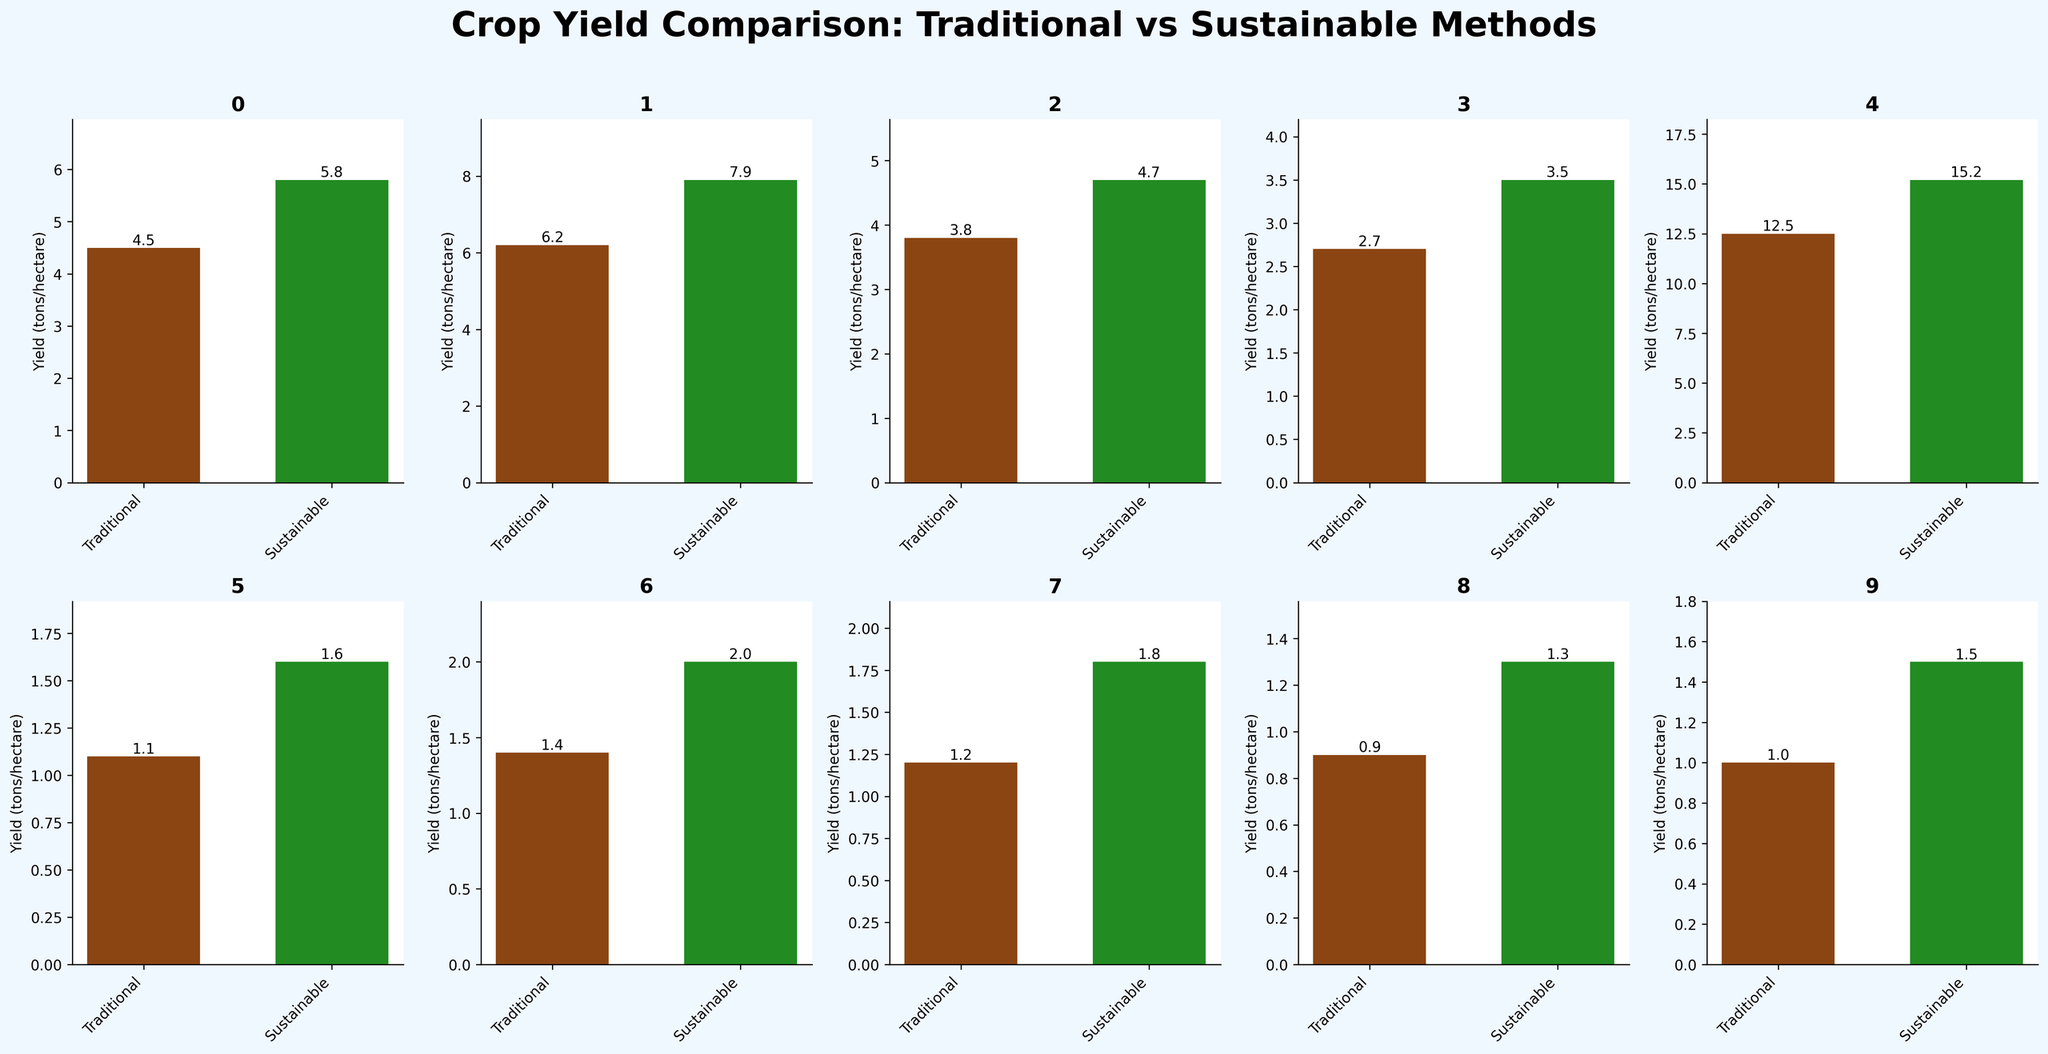Which crop has the highest yield with sustainable methods? Look at the bars representing sustainable yields for each crop. The tallest bar corresponds to Cassava.
Answer: Cassava Which crop shows the largest improvement in yield when using sustainable methods? Calculate the difference in yields between sustainable and traditional methods for each crop. Cassava has the largest increase, from 12.5 to 15.2 tons/hectare.
Answer: Cassava What's the total yield for Lentils using both traditional and sustainable methods? Add the traditional yield (1.0) and the sustainable yield (1.5) for Lentils.
Answer: 2.5 tons/hectare How much more yield does Sorghum produce with sustainable methods compared to traditional methods? Subtract the traditional yield of Sorghum (1.4) from its sustainable yield (2.0).
Answer: 0.6 tons/hectare Which crop has the smallest yield using traditional methods? Check the heights of the bars representing traditional yields. Chickpeas have the smallest traditional yield at 0.9 tons/hectare.
Answer: Chickpeas For Maize, how does the yield from sustainable methods compare to traditional methods? Look at the bars for Maize and compare their heights. The sustainable yield (7.9) is greater than the traditional yield (6.2).
Answer: Greater Which crop has a higher sustainable yield, Quinoa or Soybeans? Compare the heights of the sustainable yield bars for Quinoa (1.8) and Soybeans (3.5).
Answer: Soybeans How does the yield improvement of Rice compare to that of Wheat? Find the difference in yields for both crops between sustainable and traditional methods. Rice improves by 1.3 (5.8 - 4.5), and Wheat improves by 0.9 (4.7 - 3.8). So, Rice has a larger improvement.
Answer: Rice What's the average sustainable yield across all crops? Sum the sustainable yields for all crops and divide by the number of crops. The total is 45.3 tons/hectare, and there are 10 crops. Average yield is 45.3 / 10.
Answer: 4.53 tons/hectare 